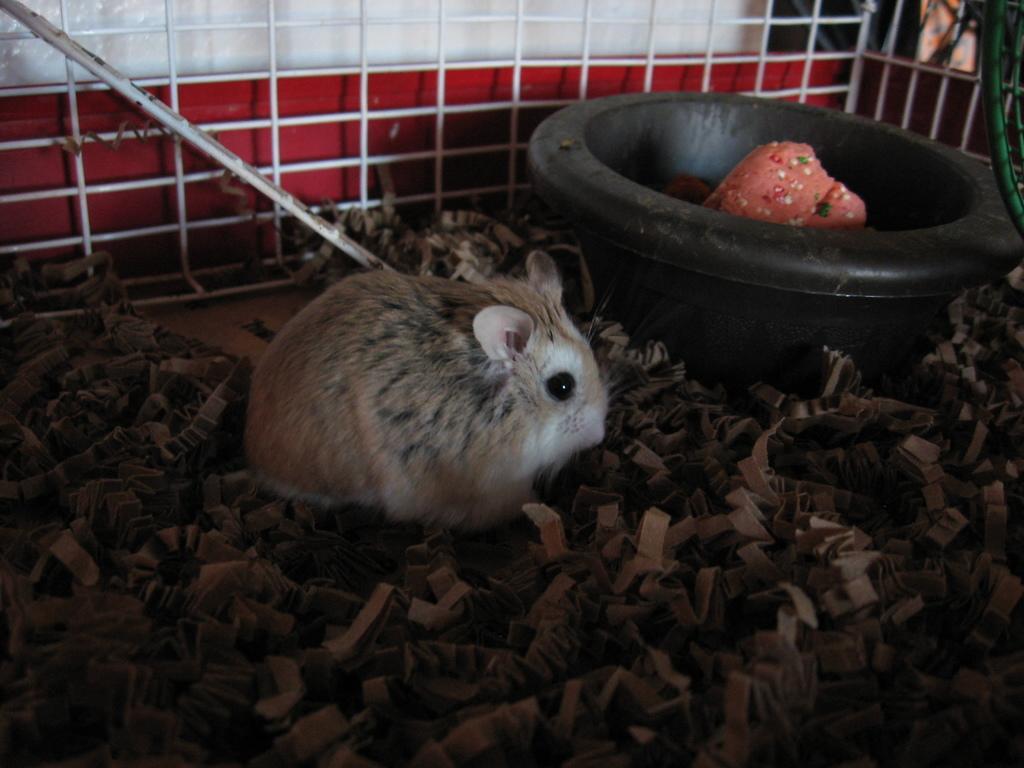How would you summarize this image in a sentence or two? In this image we can see a rabbit, there are some pieces of papers and tub with some objects in it, in the background we can see a pole, fence and the wall. 